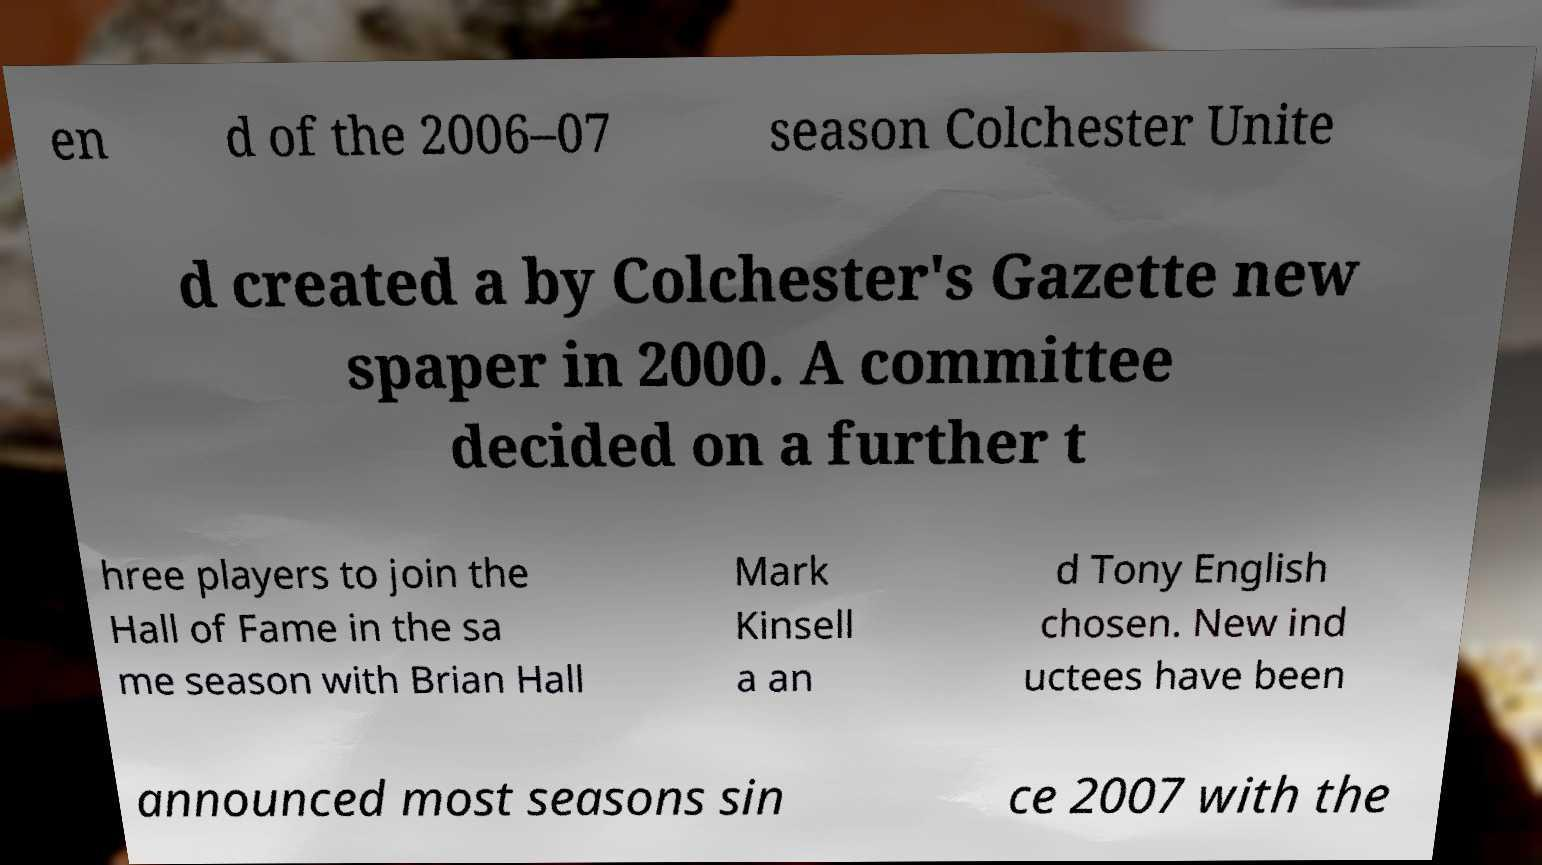Could you assist in decoding the text presented in this image and type it out clearly? en d of the 2006–07 season Colchester Unite d created a by Colchester's Gazette new spaper in 2000. A committee decided on a further t hree players to join the Hall of Fame in the sa me season with Brian Hall Mark Kinsell a an d Tony English chosen. New ind uctees have been announced most seasons sin ce 2007 with the 